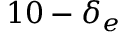Convert formula to latex. <formula><loc_0><loc_0><loc_500><loc_500>1 0 - \delta _ { e }</formula> 